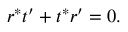<formula> <loc_0><loc_0><loc_500><loc_500>r ^ { * } t ^ { \prime } + t ^ { * } r ^ { \prime } = 0 .</formula> 